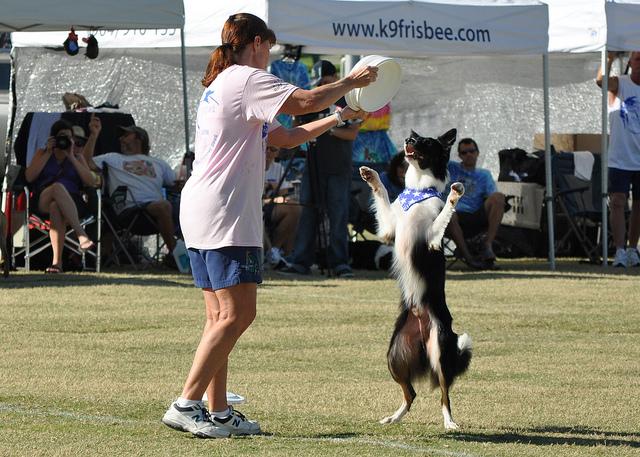What is the color of the photo?
Keep it brief. Green. What is the pattern of the dogs neckerchief?
Give a very brief answer. Stars. Is the dog standing?
Short answer required. Yes. Who is playing with the dog?
Short answer required. Woman. 